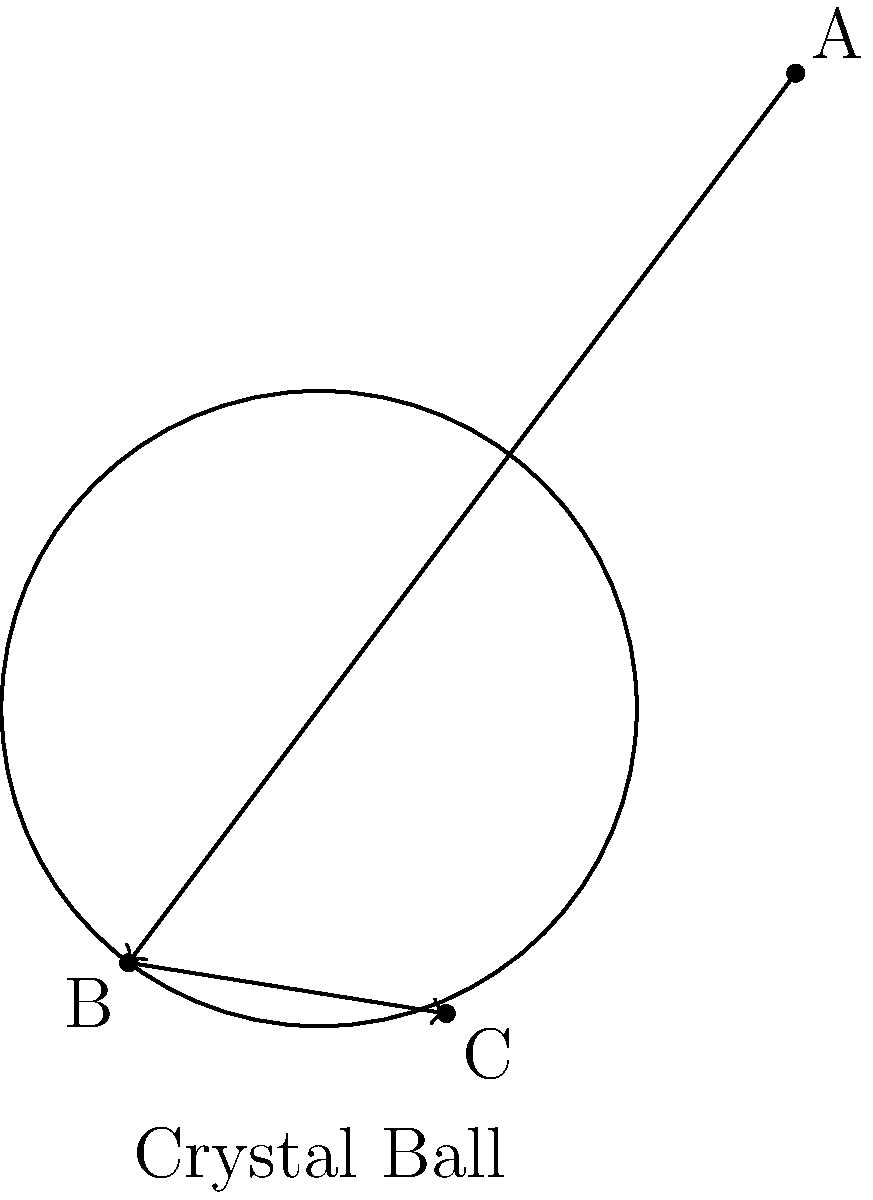In your mystical crystal ball, a beam of light enters at point A, refracts at point B on the surface, and exits at point C. If the refractive index of the crystal ball is 1.5 and the angle of incidence at point A is 30°, what is the angle of refraction at point B? (Assume the surrounding medium is air with a refractive index of 1.0) To solve this problem, we'll use Snell's law and the given information:

1. Snell's law: $n_1 \sin(\theta_1) = n_2 \sin(\theta_2)$
   Where $n_1$ and $n_2$ are the refractive indices, and $\theta_1$ and $\theta_2$ are the angles of incidence and refraction, respectively.

2. Given:
   - Angle of incidence at A: $\theta_1 = 30°$
   - Refractive index of air: $n_1 = 1.0$
   - Refractive index of crystal ball: $n_2 = 1.5$

3. Apply Snell's law:
   $1.0 \sin(30°) = 1.5 \sin(\theta_2)$

4. Solve for $\theta_2$:
   $\sin(\theta_2) = \frac{1.0 \sin(30°)}{1.5}$
   $\sin(\theta_2) = \frac{0.5}{1.5} = \frac{1}{3}$

5. Take the inverse sine (arcsin) of both sides:
   $\theta_2 = \arcsin(\frac{1}{3})$

6. Calculate the result:
   $\theta_2 \approx 19.47°$
Answer: 19.47° 